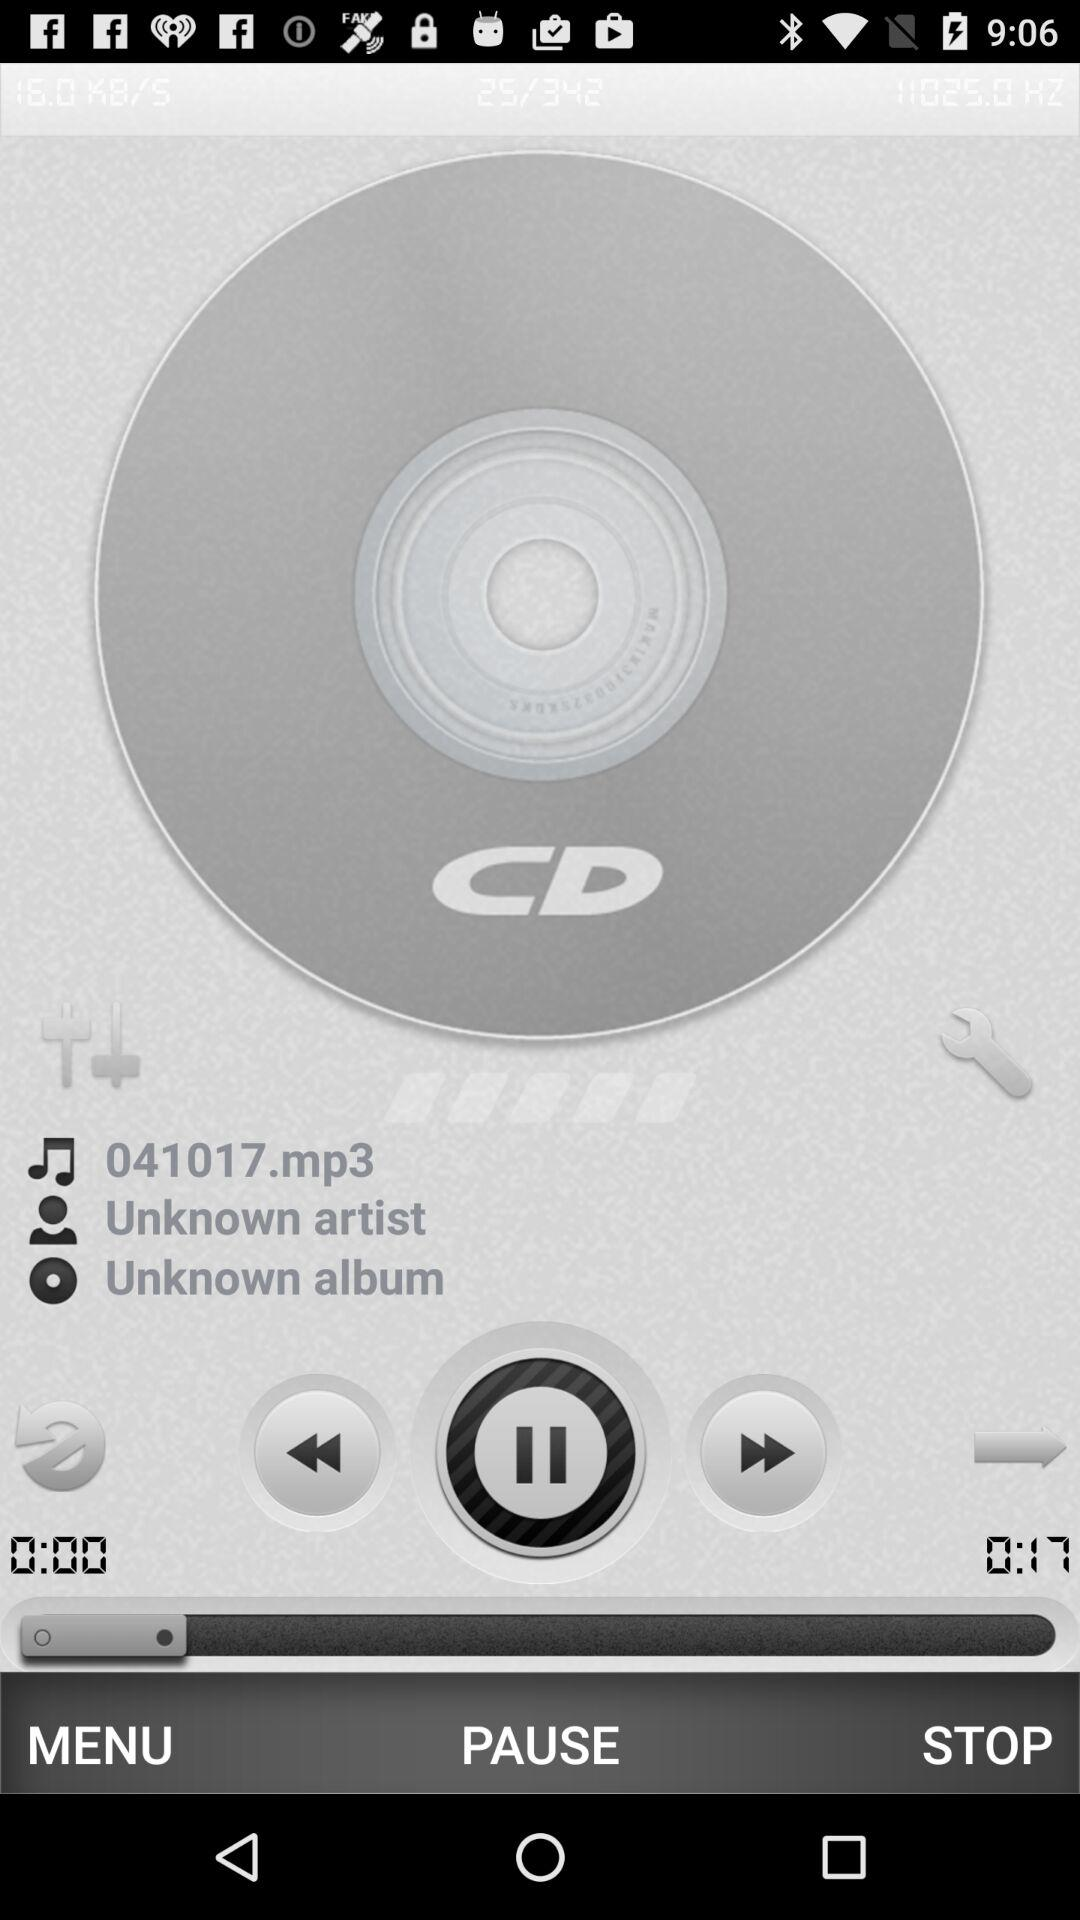What is the name of the audio? The name of the audio is "041017.mp3". 